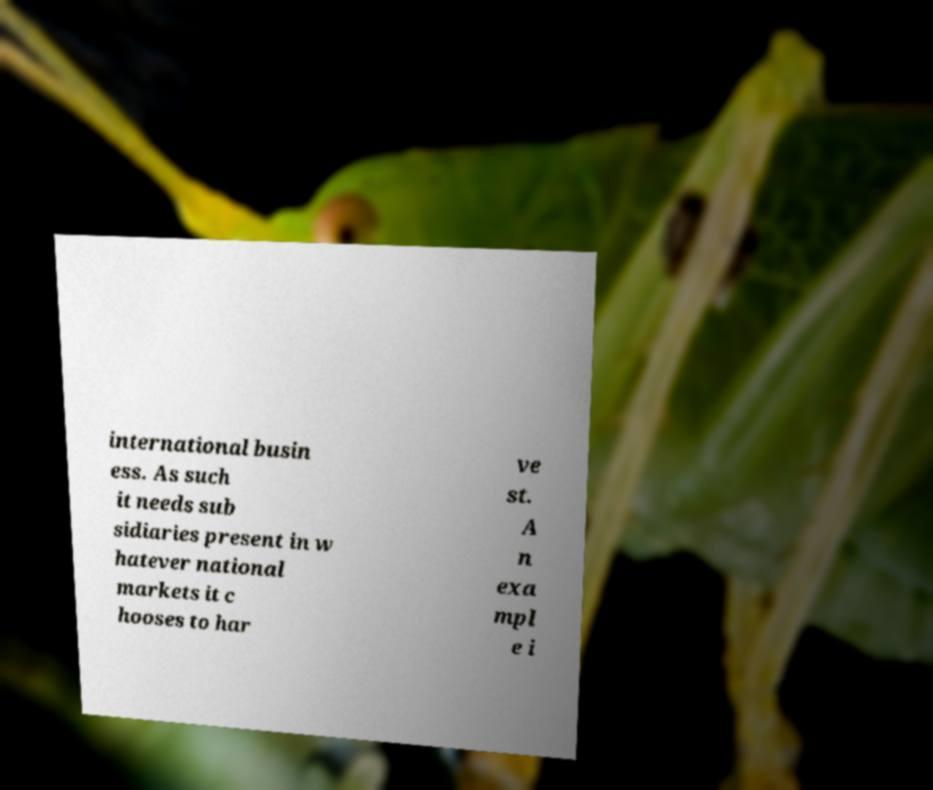Please identify and transcribe the text found in this image. international busin ess. As such it needs sub sidiaries present in w hatever national markets it c hooses to har ve st. A n exa mpl e i 